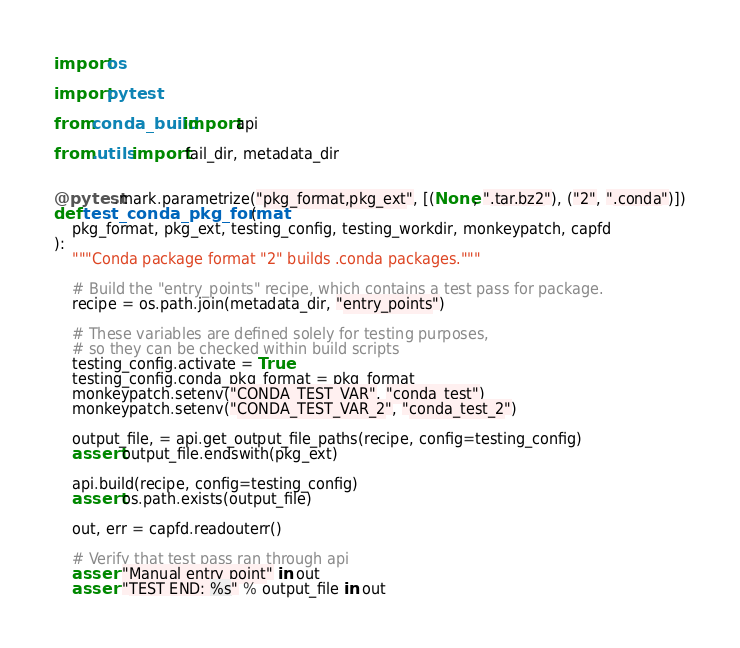<code> <loc_0><loc_0><loc_500><loc_500><_Python_>import os

import pytest

from conda_build import api

from .utils import fail_dir, metadata_dir


@pytest.mark.parametrize("pkg_format,pkg_ext", [(None, ".tar.bz2"), ("2", ".conda")])
def test_conda_pkg_format(
    pkg_format, pkg_ext, testing_config, testing_workdir, monkeypatch, capfd
):
    """Conda package format "2" builds .conda packages."""

    # Build the "entry_points" recipe, which contains a test pass for package.
    recipe = os.path.join(metadata_dir, "entry_points")

    # These variables are defined solely for testing purposes,
    # so they can be checked within build scripts
    testing_config.activate = True
    testing_config.conda_pkg_format = pkg_format
    monkeypatch.setenv("CONDA_TEST_VAR", "conda_test")
    monkeypatch.setenv("CONDA_TEST_VAR_2", "conda_test_2")

    output_file, = api.get_output_file_paths(recipe, config=testing_config)
    assert output_file.endswith(pkg_ext)

    api.build(recipe, config=testing_config)
    assert os.path.exists(output_file)

    out, err = capfd.readouterr()

    # Verify that test pass ran through api
    assert "Manual entry point" in out
    assert "TEST END: %s" % output_file in out
</code> 